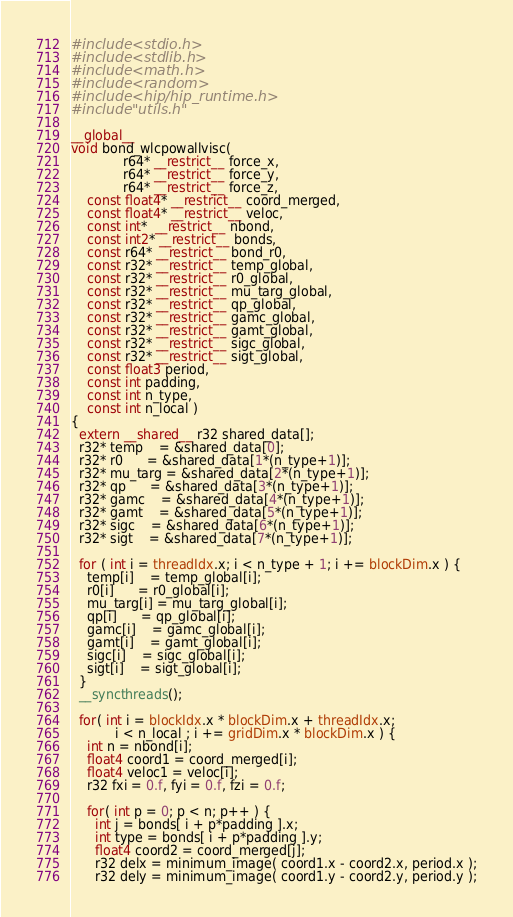<code> <loc_0><loc_0><loc_500><loc_500><_Cuda_>#include <stdio.h>
#include <stdlib.h>
#include <math.h>
#include <random>
#include <hip/hip_runtime.h>
#include "utils.h"

__global__ 
void bond_wlcpowallvisc(
             r64* __restrict__ force_x,
             r64* __restrict__ force_y,
             r64* __restrict__ force_z,
    const float4* __restrict__ coord_merged,
    const float4* __restrict__ veloc,
    const int*  __restrict__ nbond,
    const int2* __restrict__ bonds,
    const r64* __restrict__ bond_r0,
    const r32* __restrict__ temp_global,
    const r32* __restrict__ r0_global,
    const r32* __restrict__ mu_targ_global,
    const r32* __restrict__ qp_global,
    const r32* __restrict__ gamc_global,
    const r32* __restrict__ gamt_global,
    const r32* __restrict__ sigc_global,
    const r32* __restrict__ sigt_global,
    const float3 period,
    const int padding,
    const int n_type,
    const int n_local )
{
  extern __shared__ r32 shared_data[];
  r32* temp    = &shared_data[0];
  r32* r0      = &shared_data[1*(n_type+1)];
  r32* mu_targ = &shared_data[2*(n_type+1)];
  r32* qp      = &shared_data[3*(n_type+1)];
  r32* gamc    = &shared_data[4*(n_type+1)];
  r32* gamt    = &shared_data[5*(n_type+1)];
  r32* sigc    = &shared_data[6*(n_type+1)];
  r32* sigt    = &shared_data[7*(n_type+1)];

  for ( int i = threadIdx.x; i < n_type + 1; i += blockDim.x ) {
    temp[i]    = temp_global[i];
    r0[i]      = r0_global[i];
    mu_targ[i] = mu_targ_global[i];
    qp[i]      = qp_global[i];
    gamc[i]    = gamc_global[i];
    gamt[i]    = gamt_global[i];
    sigc[i]    = sigc_global[i];
    sigt[i]    = sigt_global[i];
  }
  __syncthreads();

  for( int i = blockIdx.x * blockDim.x + threadIdx.x;
           i < n_local ; i += gridDim.x * blockDim.x ) {
    int n = nbond[i];
    float4 coord1 = coord_merged[i];
    float4 veloc1 = veloc[i];
    r32 fxi = 0.f, fyi = 0.f, fzi = 0.f;

    for( int p = 0; p < n; p++ ) {
      int j = bonds[ i + p*padding ].x;
      int type = bonds[ i + p*padding ].y;
      float4 coord2 = coord_merged[j];
      r32 delx = minimum_image( coord1.x - coord2.x, period.x );
      r32 dely = minimum_image( coord1.y - coord2.y, period.y );</code> 